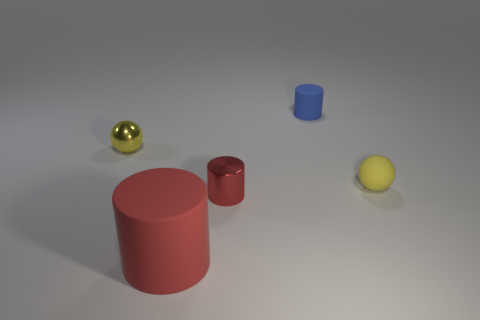Add 3 big red cylinders. How many objects exist? 8 Subtract all big red rubber cylinders. How many cylinders are left? 2 Subtract all brown spheres. How many red cylinders are left? 2 Subtract all cylinders. How many objects are left? 2 Subtract all red cylinders. How many cylinders are left? 1 Subtract 1 balls. How many balls are left? 1 Add 5 big cyan rubber cylinders. How many big cyan rubber cylinders exist? 5 Subtract 0 brown cylinders. How many objects are left? 5 Subtract all cyan cylinders. Subtract all purple spheres. How many cylinders are left? 3 Subtract all red metal things. Subtract all tiny red matte cylinders. How many objects are left? 4 